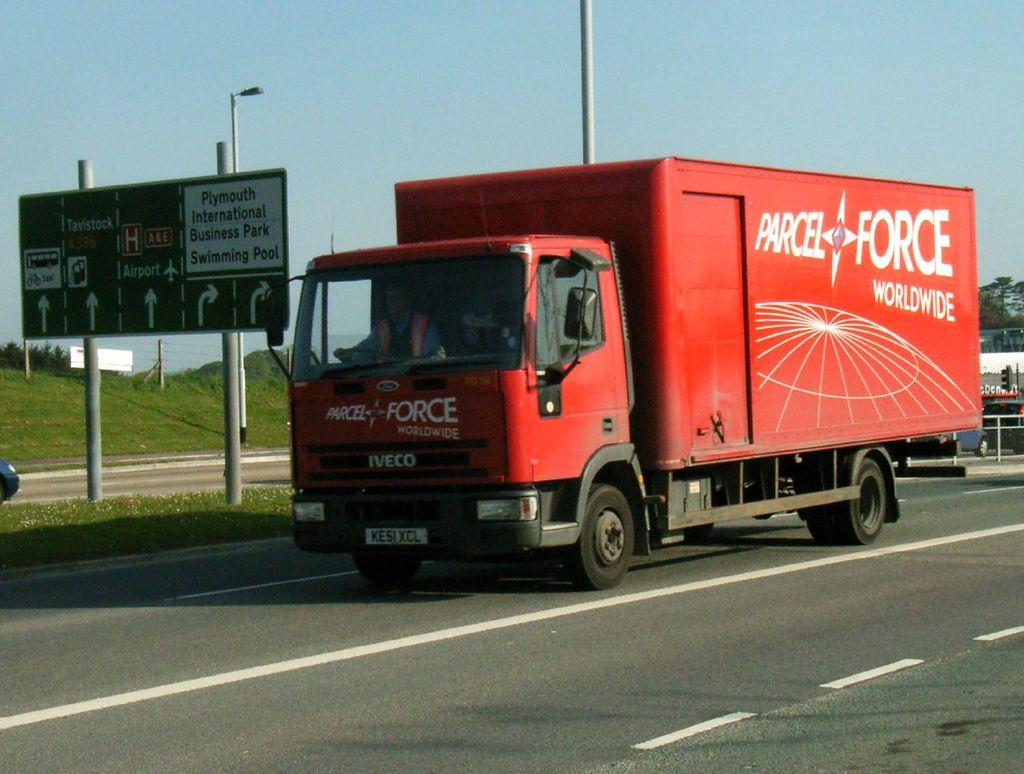What is happening on the road in the image? There are vehicles moving on the road in the image. What can be seen besides the vehicles on the road? There is a sign board and poles in the image. What is visible in the background of the image? There are trees and the sky visible in the background of the image. How many brothers are standing next to the sign board in the image? There are no brothers present in the image; it only features vehicles, a sign board, poles, trees, and the sky. What word is written on the chain that is hanging from the sign board? There is no chain hanging from the sign board in the image. 